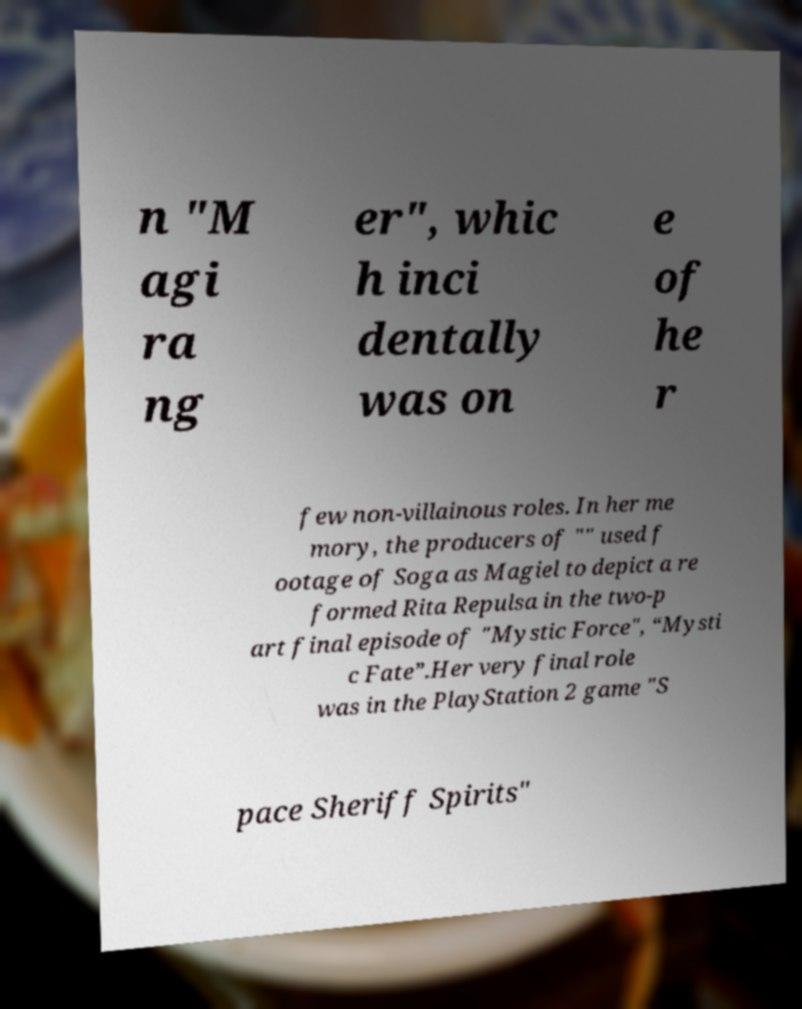Please identify and transcribe the text found in this image. n "M agi ra ng er", whic h inci dentally was on e of he r few non-villainous roles. In her me mory, the producers of "" used f ootage of Soga as Magiel to depict a re formed Rita Repulsa in the two-p art final episode of "Mystic Force", “Mysti c Fate”.Her very final role was in the PlayStation 2 game "S pace Sheriff Spirits" 